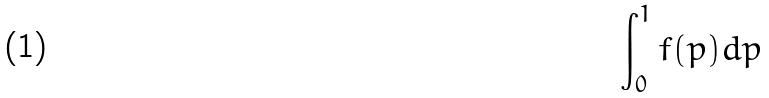<formula> <loc_0><loc_0><loc_500><loc_500>\int _ { 0 } ^ { 1 } f ( p ) d p</formula> 